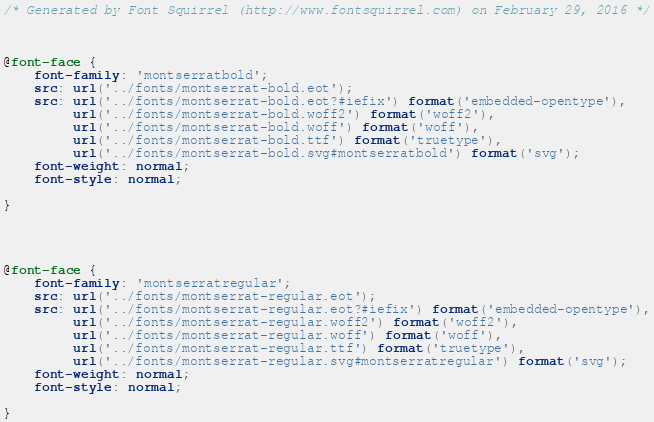Convert code to text. <code><loc_0><loc_0><loc_500><loc_500><_CSS_>/* Generated by Font Squirrel (http://www.fontsquirrel.com) on February 29, 2016 */



@font-face {
    font-family: 'montserratbold';
    src: url('../fonts/montserrat-bold.eot');
    src: url('../fonts/montserrat-bold.eot?#iefix') format('embedded-opentype'),
         url('../fonts/montserrat-bold.woff2') format('woff2'),
         url('../fonts/montserrat-bold.woff') format('woff'),
         url('../fonts/montserrat-bold.ttf') format('truetype'),
         url('../fonts/montserrat-bold.svg#montserratbold') format('svg');
    font-weight: normal;
    font-style: normal;

}




@font-face {
    font-family: 'montserratregular';
    src: url('../fonts/montserrat-regular.eot');
    src: url('../fonts/montserrat-regular.eot?#iefix') format('embedded-opentype'),
         url('../fonts/montserrat-regular.woff2') format('woff2'),
         url('../fonts/montserrat-regular.woff') format('woff'),
         url('../fonts/montserrat-regular.ttf') format('truetype'),
         url('../fonts/montserrat-regular.svg#montserratregular') format('svg');
    font-weight: normal;
    font-style: normal;

}</code> 